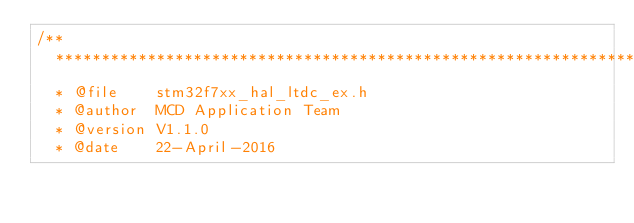Convert code to text. <code><loc_0><loc_0><loc_500><loc_500><_C_>/**
  ******************************************************************************
  * @file    stm32f7xx_hal_ltdc_ex.h
  * @author  MCD Application Team
  * @version V1.1.0
  * @date    22-April-2016</code> 